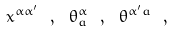Convert formula to latex. <formula><loc_0><loc_0><loc_500><loc_500>x ^ { \alpha \alpha ^ { \prime } } \ , \ \theta ^ { \alpha } _ { a } \ , \ \theta ^ { \alpha ^ { \prime } a } \ ,</formula> 